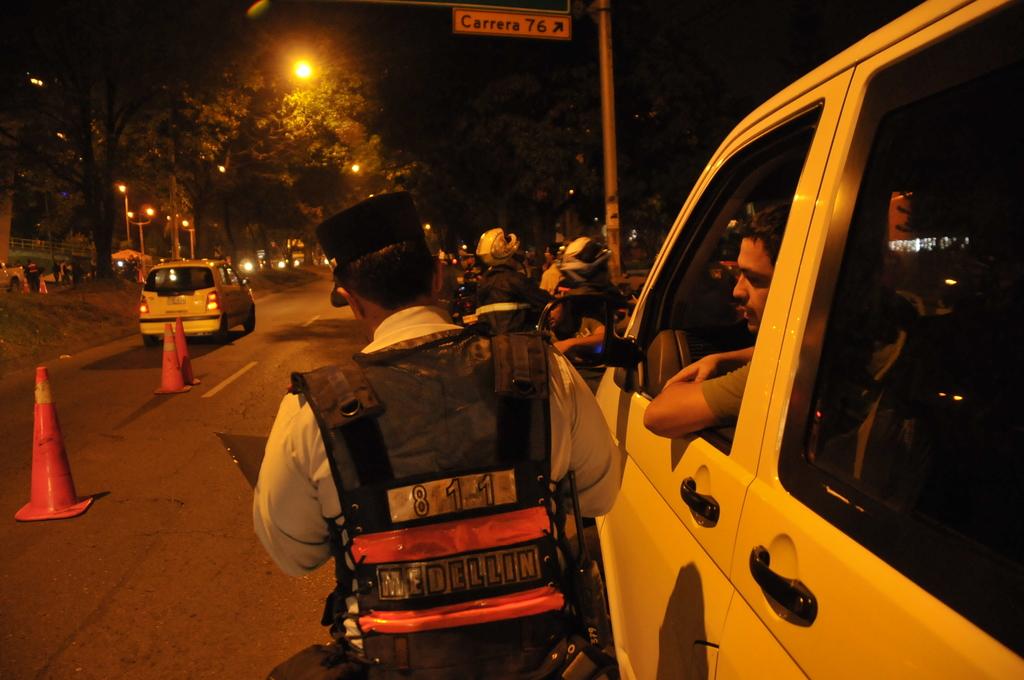What road is up ahead on the right?
Your response must be concise. Carrera 76. How many traffic cones are in the picture?
Ensure brevity in your answer.  3. 